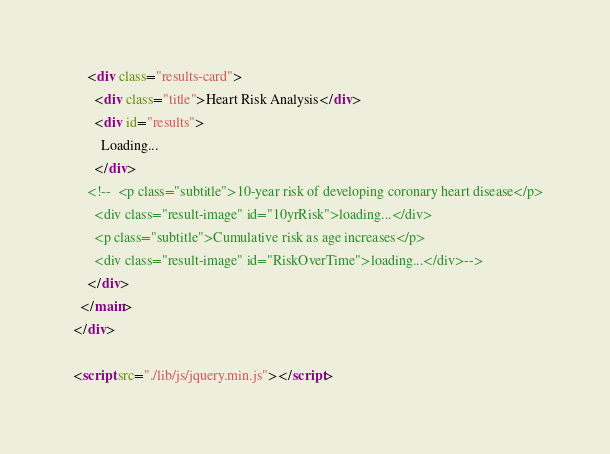<code> <loc_0><loc_0><loc_500><loc_500><_HTML_>      <div class="results-card">
        <div class="title">Heart Risk Analysis</div>
        <div id="results">
          Loading...
        </div>
      <!--  <p class="subtitle">10-year risk of developing coronary heart disease</p>
        <div class="result-image" id="10yrRisk">loading...</div>
        <p class="subtitle">Cumulative risk as age increases</p>
        <div class="result-image" id="RiskOverTime">loading...</div>-->
      </div>
    </main>
  </div>

  <script src="./lib/js/jquery.min.js"></script></code> 